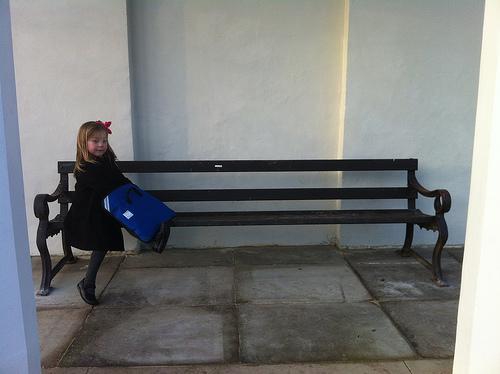How many girls are there?
Give a very brief answer. 1. How many of this child's feet are resting on the ground?
Give a very brief answer. 1. 